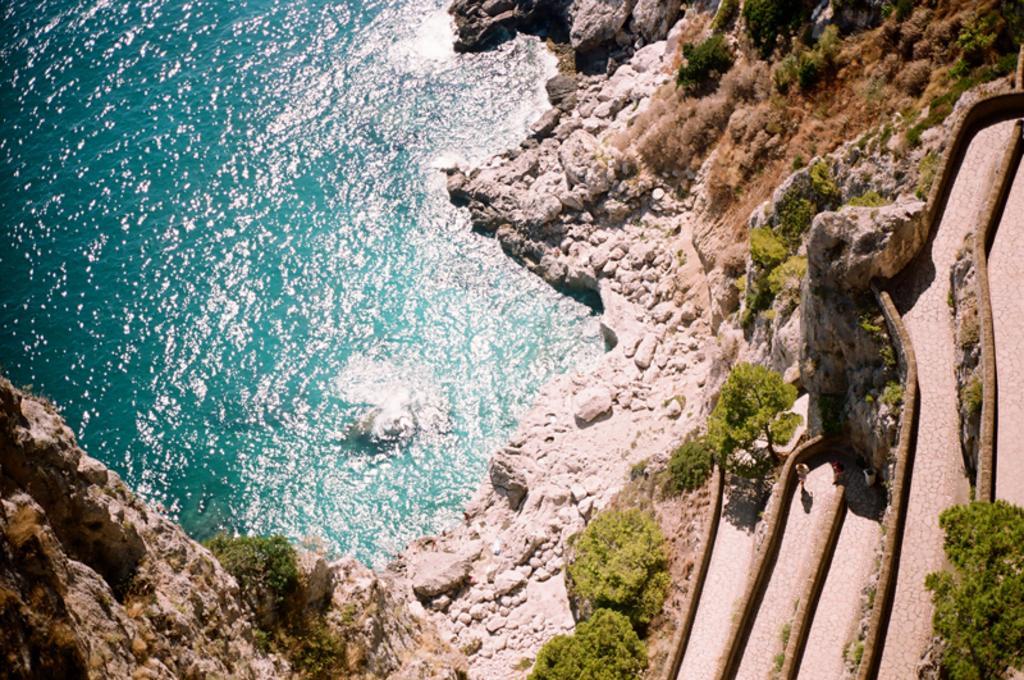Describe this image in one or two sentences. In this picture we are able to see river with fresh blue water. the river is surrounded by stones and trees. Here we can see three persons standing in front of the river. 